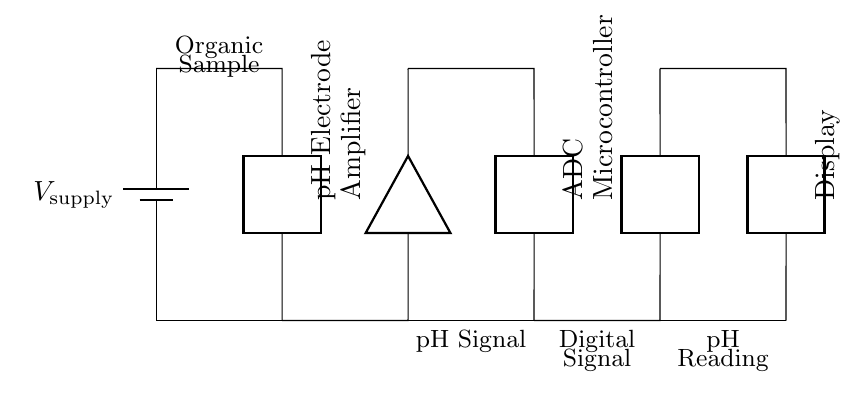What is the first component in the circuit? The first component shown in the circuit diagram is a battery, which indicates the power source for the circuit.
Answer: Battery What type of component is used for pH measurement? The component used for pH measurement is a pH electrode, designed to detect the hydrogen ion concentration in the organic sample.
Answer: pH Electrode How many main components are in the circuit? Counting the battery, pH electrode, amplifier, ADC, microcontroller, and display, there are a total of six main components in this series circuit.
Answer: Six What does the ADC stand for? ADC stands for Analog-to-Digital Converter, which converts the analog signal from the pH electrode into a digital signal for processing.
Answer: Analog-to-Digital Converter What is the purpose of the amplifier in this circuit? The amplifier is used to enhance the weak pH signal from the electrode before it is sent to the ADC, ensuring that the signal is strong enough for accurate measurement.
Answer: To enhance the pH signal Which component displays the pH readings? The component responsible for displaying the pH readings is the display, which shows the processed information to the user.
Answer: Display What sequence does the signal travel through from the pH electrode to the display? The signal travels from the pH electrode to the amplifier, then to the ADC, followed by the microcontroller, and finally to the display for output.
Answer: pH Electrode → Amplifier → ADC → Microcontroller → Display 